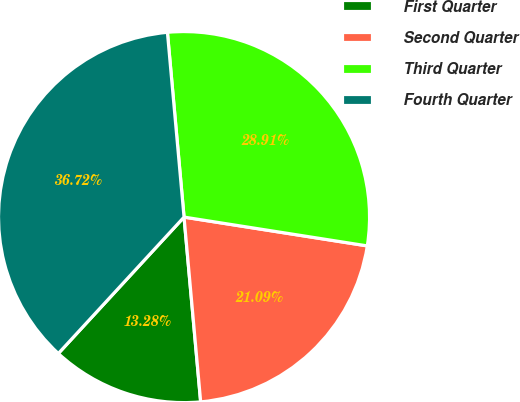Convert chart. <chart><loc_0><loc_0><loc_500><loc_500><pie_chart><fcel>First Quarter<fcel>Second Quarter<fcel>Third Quarter<fcel>Fourth Quarter<nl><fcel>13.28%<fcel>21.09%<fcel>28.91%<fcel>36.72%<nl></chart> 